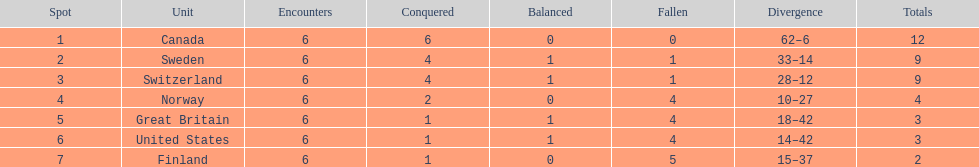What was the number of points won by great britain? 3. 